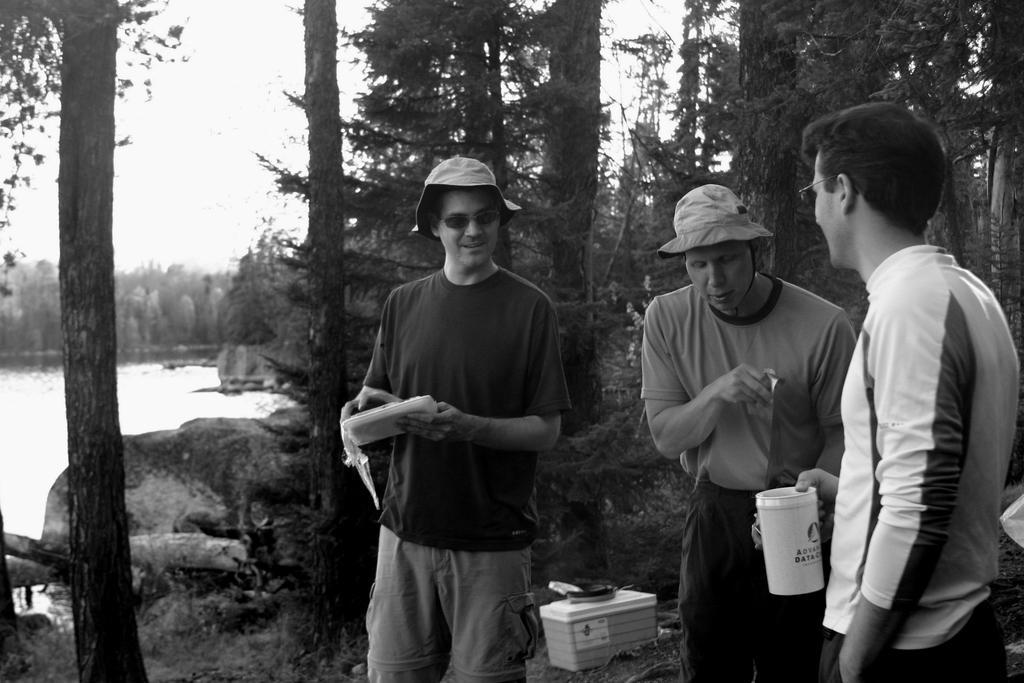In one or two sentences, can you explain what this image depicts? In the image few people are standing and holding something in their hands. Behind them them there are some boxes and trees. On the left side of the image we can see water. Behind the trees there is sky. 